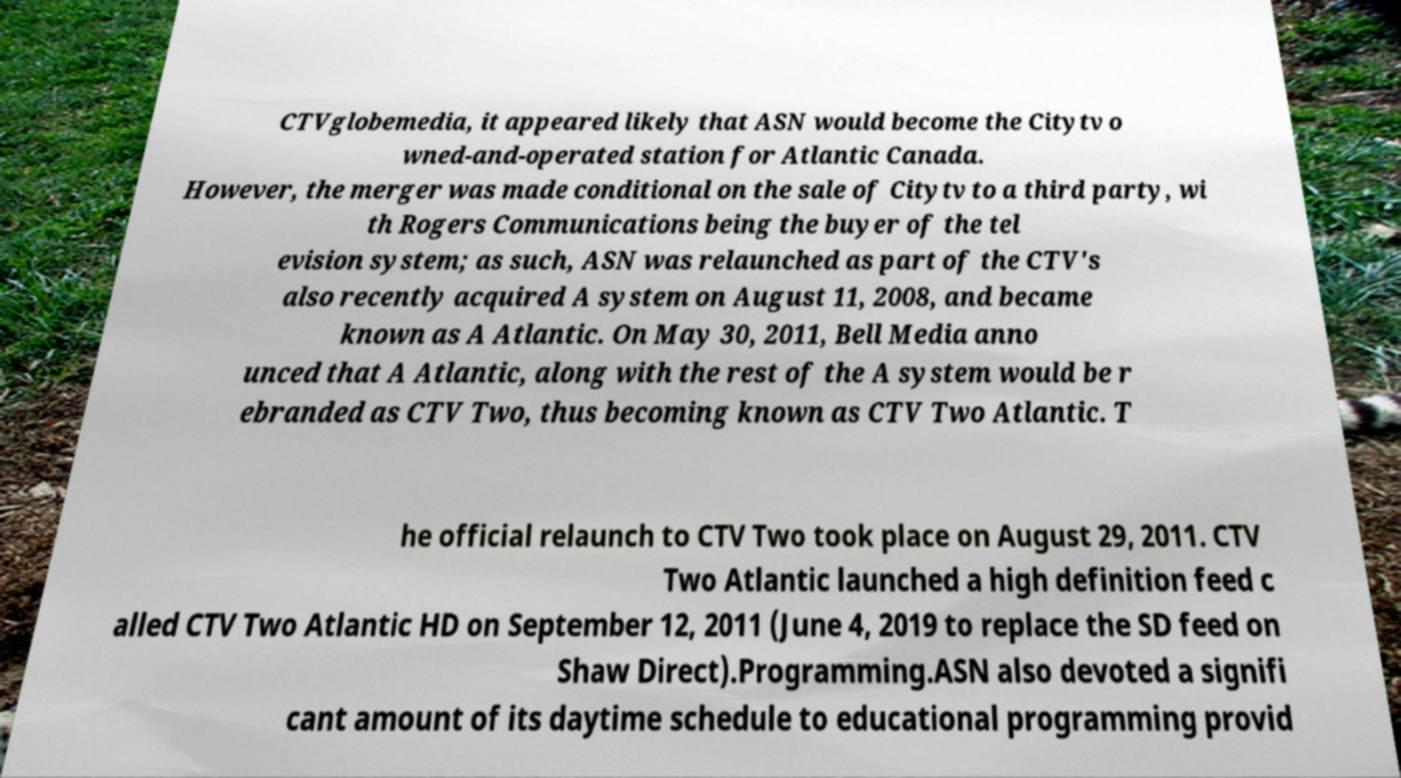Could you extract and type out the text from this image? CTVglobemedia, it appeared likely that ASN would become the Citytv o wned-and-operated station for Atlantic Canada. However, the merger was made conditional on the sale of Citytv to a third party, wi th Rogers Communications being the buyer of the tel evision system; as such, ASN was relaunched as part of the CTV's also recently acquired A system on August 11, 2008, and became known as A Atlantic. On May 30, 2011, Bell Media anno unced that A Atlantic, along with the rest of the A system would be r ebranded as CTV Two, thus becoming known as CTV Two Atlantic. T he official relaunch to CTV Two took place on August 29, 2011. CTV Two Atlantic launched a high definition feed c alled CTV Two Atlantic HD on September 12, 2011 (June 4, 2019 to replace the SD feed on Shaw Direct).Programming.ASN also devoted a signifi cant amount of its daytime schedule to educational programming provid 